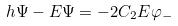<formula> <loc_0><loc_0><loc_500><loc_500>h \Psi - E \Psi = - 2 C _ { 2 } E \varphi _ { - }</formula> 